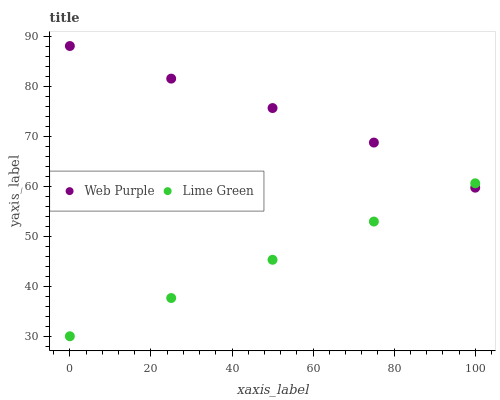Does Lime Green have the minimum area under the curve?
Answer yes or no. Yes. Does Web Purple have the maximum area under the curve?
Answer yes or no. Yes. Does Lime Green have the maximum area under the curve?
Answer yes or no. No. Is Lime Green the smoothest?
Answer yes or no. Yes. Is Web Purple the roughest?
Answer yes or no. Yes. Is Lime Green the roughest?
Answer yes or no. No. Does Lime Green have the lowest value?
Answer yes or no. Yes. Does Web Purple have the highest value?
Answer yes or no. Yes. Does Lime Green have the highest value?
Answer yes or no. No. Does Lime Green intersect Web Purple?
Answer yes or no. Yes. Is Lime Green less than Web Purple?
Answer yes or no. No. Is Lime Green greater than Web Purple?
Answer yes or no. No. 